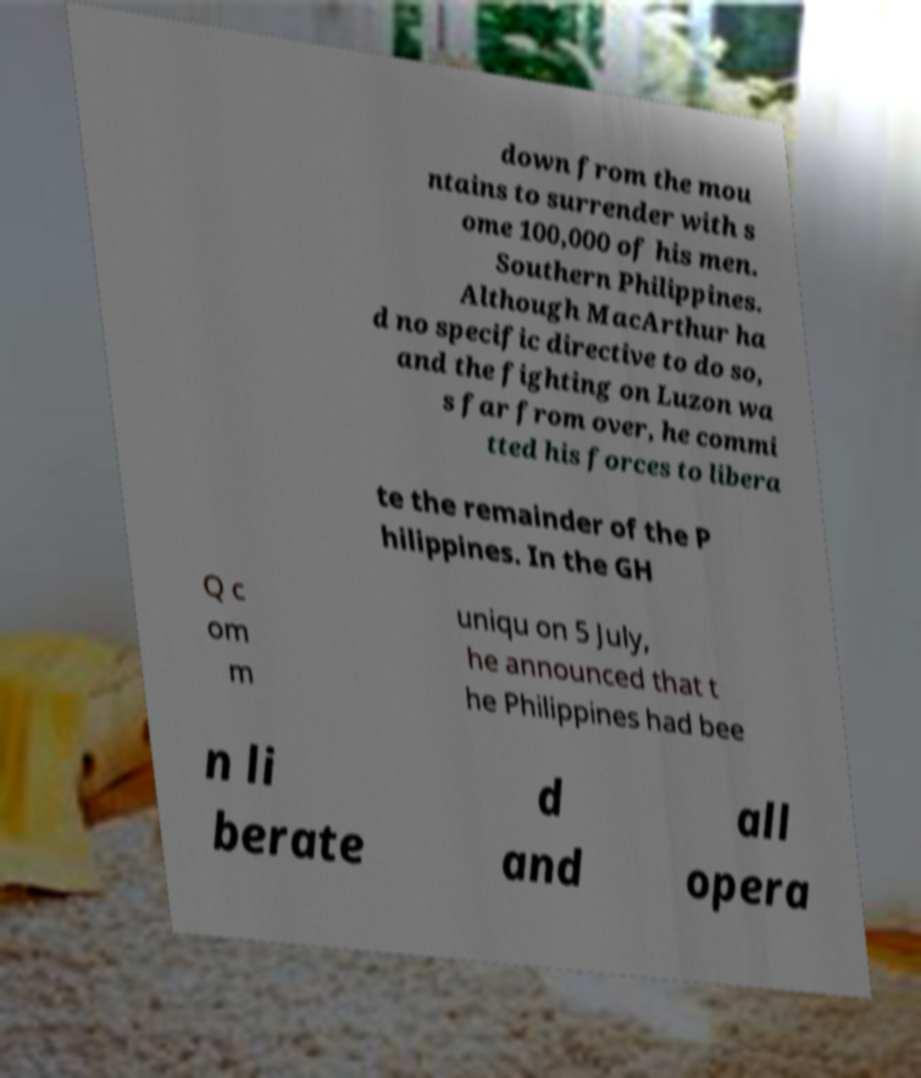Please read and relay the text visible in this image. What does it say? down from the mou ntains to surrender with s ome 100,000 of his men. Southern Philippines. Although MacArthur ha d no specific directive to do so, and the fighting on Luzon wa s far from over, he commi tted his forces to libera te the remainder of the P hilippines. In the GH Q c om m uniqu on 5 July, he announced that t he Philippines had bee n li berate d and all opera 